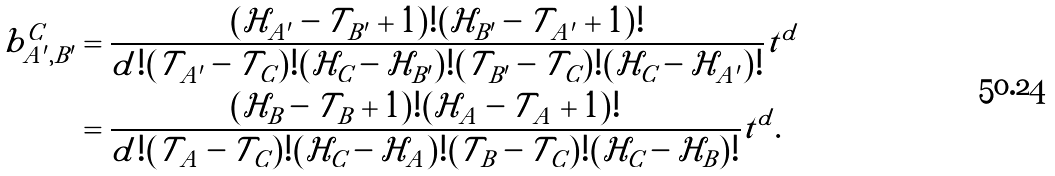<formula> <loc_0><loc_0><loc_500><loc_500>b _ { A ^ { \prime } , B ^ { \prime } } ^ { C } & = \frac { ( \mathcal { H } _ { A ^ { \prime } } - \mathcal { T } _ { B ^ { \prime } } + 1 ) ! ( \mathcal { H } _ { B ^ { \prime } } - \mathcal { T } _ { A ^ { \prime } } + 1 ) ! } { d ! ( \mathcal { T } _ { A ^ { \prime } } - \mathcal { T } _ { C } ) ! ( \mathcal { H } _ { C } - \mathcal { H } _ { B ^ { \prime } } ) ! ( \mathcal { T } _ { B ^ { \prime } } - \mathcal { T } _ { C } ) ! ( \mathcal { H } _ { C } - \mathcal { H } _ { A ^ { \prime } } ) ! } t ^ { d } \\ & = \frac { ( \mathcal { H } _ { B } - \mathcal { T } _ { B } + 1 ) ! ( \mathcal { H } _ { A } - \mathcal { T } _ { A } + 1 ) ! } { d ! ( \mathcal { T } _ { A } - \mathcal { T } _ { C } ) ! ( \mathcal { H } _ { C } - \mathcal { H } _ { A } ) ! ( \mathcal { T } _ { B } - \mathcal { T } _ { C } ) ! ( \mathcal { H } _ { C } - \mathcal { H } _ { B } ) ! } t ^ { d } .</formula> 